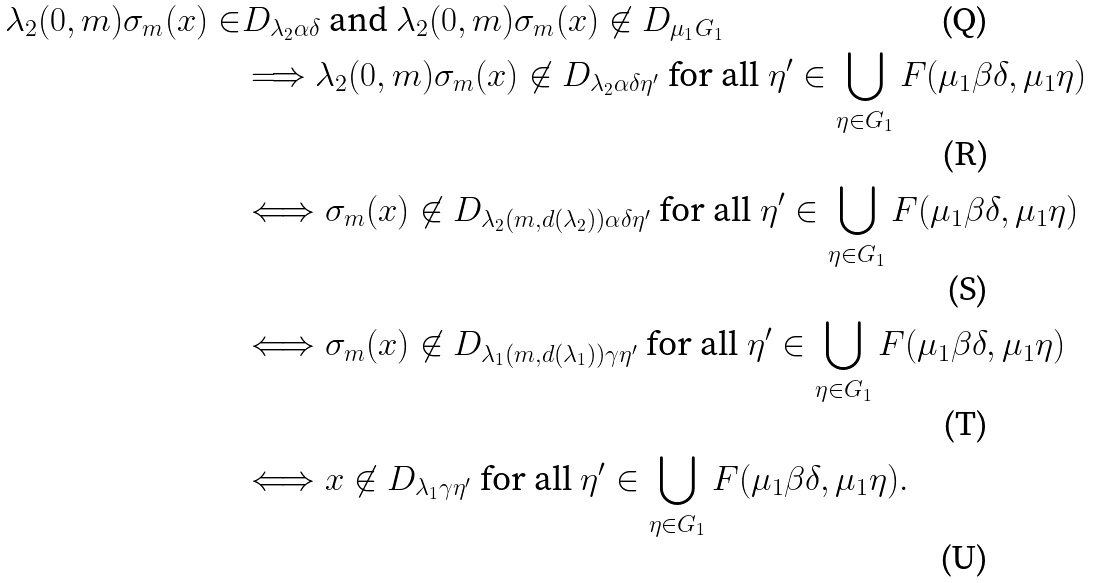<formula> <loc_0><loc_0><loc_500><loc_500>\lambda _ { 2 } ( 0 , m ) \sigma _ { m } ( x ) \in & D _ { \lambda _ { 2 } \alpha \delta } \text { and } \lambda _ { 2 } ( 0 , m ) \sigma _ { m } ( x ) \not \in D _ { \mu _ { 1 } G _ { 1 } } \\ & \Longrightarrow \lambda _ { 2 } ( 0 , m ) \sigma _ { m } ( x ) \not \in D _ { \lambda _ { 2 } \alpha \delta \eta ^ { \prime } } \text { for all } \eta ^ { \prime } \in \bigcup _ { \eta \in G _ { 1 } } F ( \mu _ { 1 } \beta \delta , \mu _ { 1 } \eta ) \\ & \Longleftrightarrow \sigma _ { m } ( x ) \not \in D _ { \lambda _ { 2 } ( m , d ( \lambda _ { 2 } ) ) \alpha \delta \eta ^ { \prime } } \text { for all } \eta ^ { \prime } \in \bigcup _ { \eta \in G _ { 1 } } F ( \mu _ { 1 } \beta \delta , \mu _ { 1 } \eta ) \\ & \Longleftrightarrow \sigma _ { m } ( x ) \not \in D _ { \lambda _ { 1 } ( m , d ( \lambda _ { 1 } ) ) \gamma \eta ^ { \prime } } \text { for all } \eta ^ { \prime } \in \bigcup _ { \eta \in G _ { 1 } } F ( \mu _ { 1 } \beta \delta , \mu _ { 1 } \eta ) \\ & \Longleftrightarrow x \not \in D _ { \lambda _ { 1 } \gamma \eta ^ { \prime } } \text { for all } \eta ^ { \prime } \in \bigcup _ { \eta \in G _ { 1 } } F ( \mu _ { 1 } \beta \delta , \mu _ { 1 } \eta ) .</formula> 